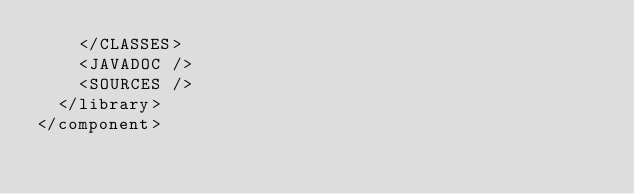<code> <loc_0><loc_0><loc_500><loc_500><_XML_>    </CLASSES>
    <JAVADOC />
    <SOURCES />
  </library>
</component></code> 